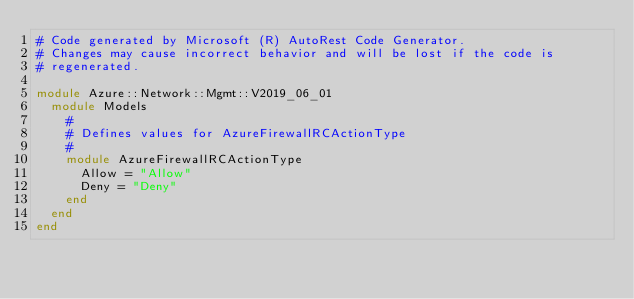Convert code to text. <code><loc_0><loc_0><loc_500><loc_500><_Ruby_># Code generated by Microsoft (R) AutoRest Code Generator.
# Changes may cause incorrect behavior and will be lost if the code is
# regenerated.

module Azure::Network::Mgmt::V2019_06_01
  module Models
    #
    # Defines values for AzureFirewallRCActionType
    #
    module AzureFirewallRCActionType
      Allow = "Allow"
      Deny = "Deny"
    end
  end
end
</code> 